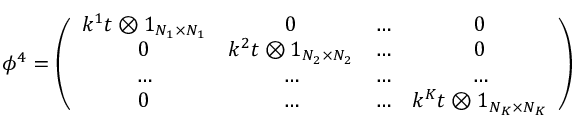<formula> <loc_0><loc_0><loc_500><loc_500>\phi ^ { 4 } = \left ( \begin{array} { c c c c } { { k ^ { 1 } t \otimes 1 _ { N _ { 1 } \times N _ { 1 } } } } & { 0 } & { \dots } & { 0 } \\ { 0 } & { { k ^ { 2 } t \otimes 1 _ { N _ { 2 } \times N _ { 2 } } } } & { \dots } & { 0 } \\ { \dots } & { \dots } & { \dots } & { \dots } \\ { 0 } & { \dots } & { \dots } & { { k ^ { K } t \otimes 1 _ { N _ { K } \times N _ { K } } } } \end{array} \right )</formula> 